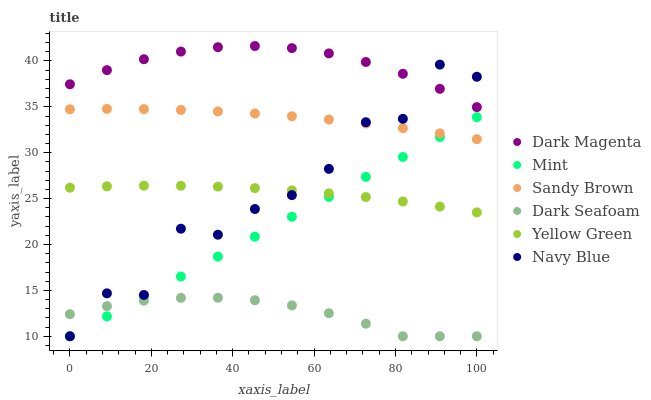Does Dark Seafoam have the minimum area under the curve?
Answer yes or no. Yes. Does Dark Magenta have the maximum area under the curve?
Answer yes or no. Yes. Does Mint have the minimum area under the curve?
Answer yes or no. No. Does Mint have the maximum area under the curve?
Answer yes or no. No. Is Mint the smoothest?
Answer yes or no. Yes. Is Navy Blue the roughest?
Answer yes or no. Yes. Is Dark Seafoam the smoothest?
Answer yes or no. No. Is Dark Seafoam the roughest?
Answer yes or no. No. Does Mint have the lowest value?
Answer yes or no. Yes. Does Sandy Brown have the lowest value?
Answer yes or no. No. Does Dark Magenta have the highest value?
Answer yes or no. Yes. Does Mint have the highest value?
Answer yes or no. No. Is Dark Seafoam less than Yellow Green?
Answer yes or no. Yes. Is Yellow Green greater than Dark Seafoam?
Answer yes or no. Yes. Does Sandy Brown intersect Mint?
Answer yes or no. Yes. Is Sandy Brown less than Mint?
Answer yes or no. No. Is Sandy Brown greater than Mint?
Answer yes or no. No. Does Dark Seafoam intersect Yellow Green?
Answer yes or no. No. 